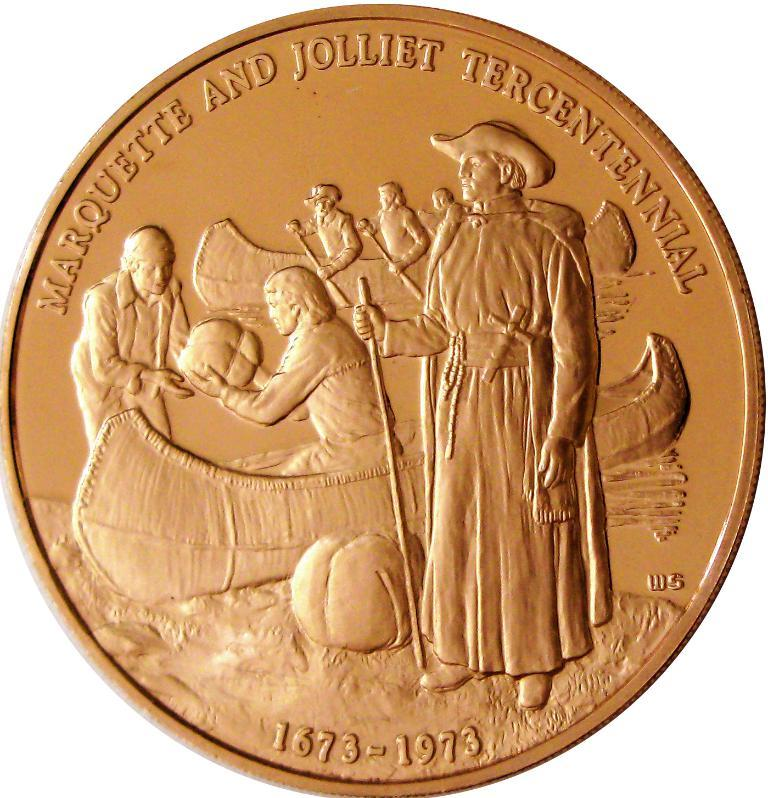<image>
Present a compact description of the photo's key features. A copper coin that has the headline Marquette And Jolliet Tercentennial on it. 